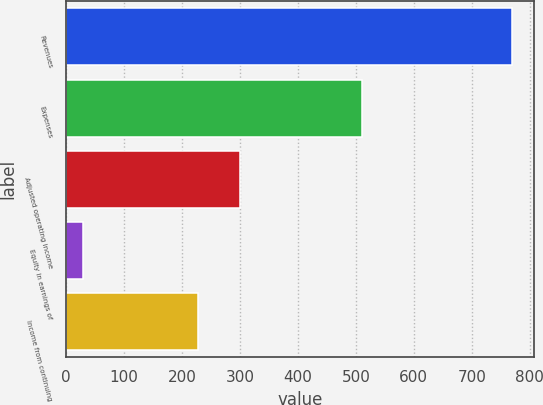<chart> <loc_0><loc_0><loc_500><loc_500><bar_chart><fcel>Revenues<fcel>Expenses<fcel>Adjusted operating income<fcel>Equity in earnings of<fcel>Income from continuing<nl><fcel>769<fcel>510<fcel>300.9<fcel>30<fcel>227<nl></chart> 